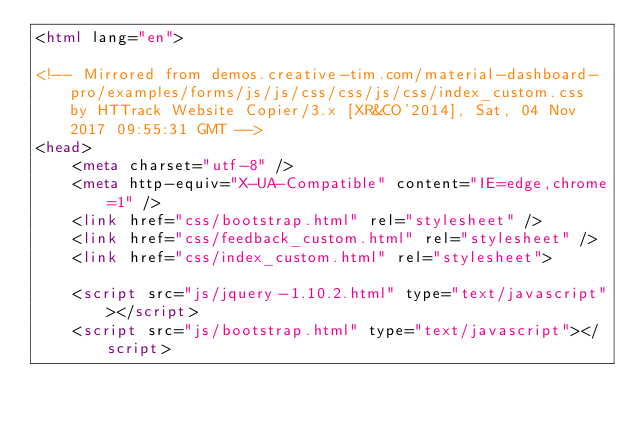<code> <loc_0><loc_0><loc_500><loc_500><_HTML_><html lang="en">

<!-- Mirrored from demos.creative-tim.com/material-dashboard-pro/examples/forms/js/js/css/css/js/css/index_custom.css by HTTrack Website Copier/3.x [XR&CO'2014], Sat, 04 Nov 2017 09:55:31 GMT -->
<head>
	<meta charset="utf-8" />
	<meta http-equiv="X-UA-Compatible" content="IE=edge,chrome=1" />
    <link href="css/bootstrap.html" rel="stylesheet" />
	<link href="css/feedback_custom.html" rel="stylesheet" />
	<link href="css/index_custom.html" rel="stylesheet">

	<script src="js/jquery-1.10.2.html" type="text/javascript"></script>
	<script src="js/bootstrap.html" type="text/javascript"></script></code> 